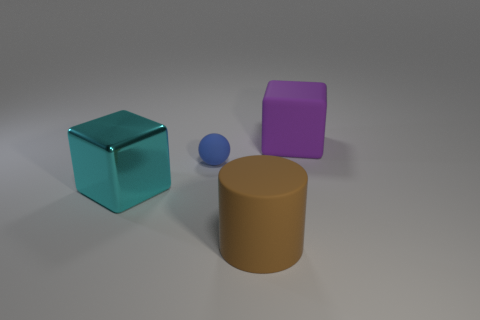What material is the small sphere?
Give a very brief answer. Rubber. There is a rubber thing that is in front of the tiny blue thing; what is its color?
Offer a terse response. Brown. What number of large things are matte blocks or matte spheres?
Offer a very short reply. 1. Is the color of the big thing that is to the left of the tiny thing the same as the large matte thing behind the large brown matte cylinder?
Ensure brevity in your answer.  No. How many other things are the same color as the large shiny block?
Offer a very short reply. 0. How many purple things are either big cubes or metallic blocks?
Provide a succinct answer. 1. There is a large purple rubber object; does it have the same shape as the rubber thing that is on the left side of the cylinder?
Your answer should be compact. No. The big brown rubber thing has what shape?
Keep it short and to the point. Cylinder. What is the material of the cylinder that is the same size as the rubber cube?
Offer a very short reply. Rubber. Is there anything else that is the same size as the blue sphere?
Keep it short and to the point. No. 